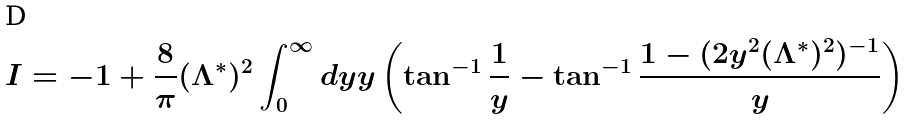<formula> <loc_0><loc_0><loc_500><loc_500>I = - 1 + \frac { 8 } { \pi } ( \Lambda ^ { * } ) ^ { 2 } \int _ { 0 } ^ { \infty } d y y \left ( \tan ^ { - 1 } \frac { 1 } { y } - \tan ^ { - 1 } \frac { 1 - ( 2 y ^ { 2 } ( \Lambda ^ { * } ) ^ { 2 } ) ^ { - 1 } } { y } \right )</formula> 